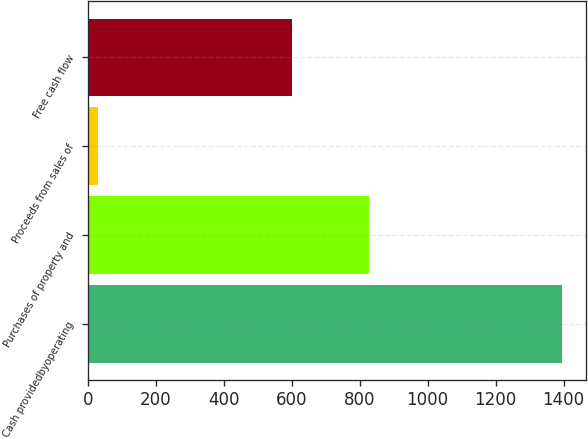Convert chart to OTSL. <chart><loc_0><loc_0><loc_500><loc_500><bar_chart><fcel>Cash providedbyoperating<fcel>Purchases of property and<fcel>Proceeds from sales of<fcel>Free cash flow<nl><fcel>1396.5<fcel>826.3<fcel>31.8<fcel>602<nl></chart> 